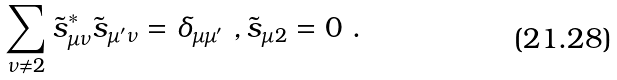<formula> <loc_0><loc_0><loc_500><loc_500>\sum _ { \nu \ne 2 } \tilde { s } ^ { * } _ { \mu \nu } \tilde { s } _ { \mu ^ { \prime } \nu } = \delta _ { \mu \mu ^ { \prime } } \ , \tilde { s } _ { \mu 2 } = 0 \ .</formula> 